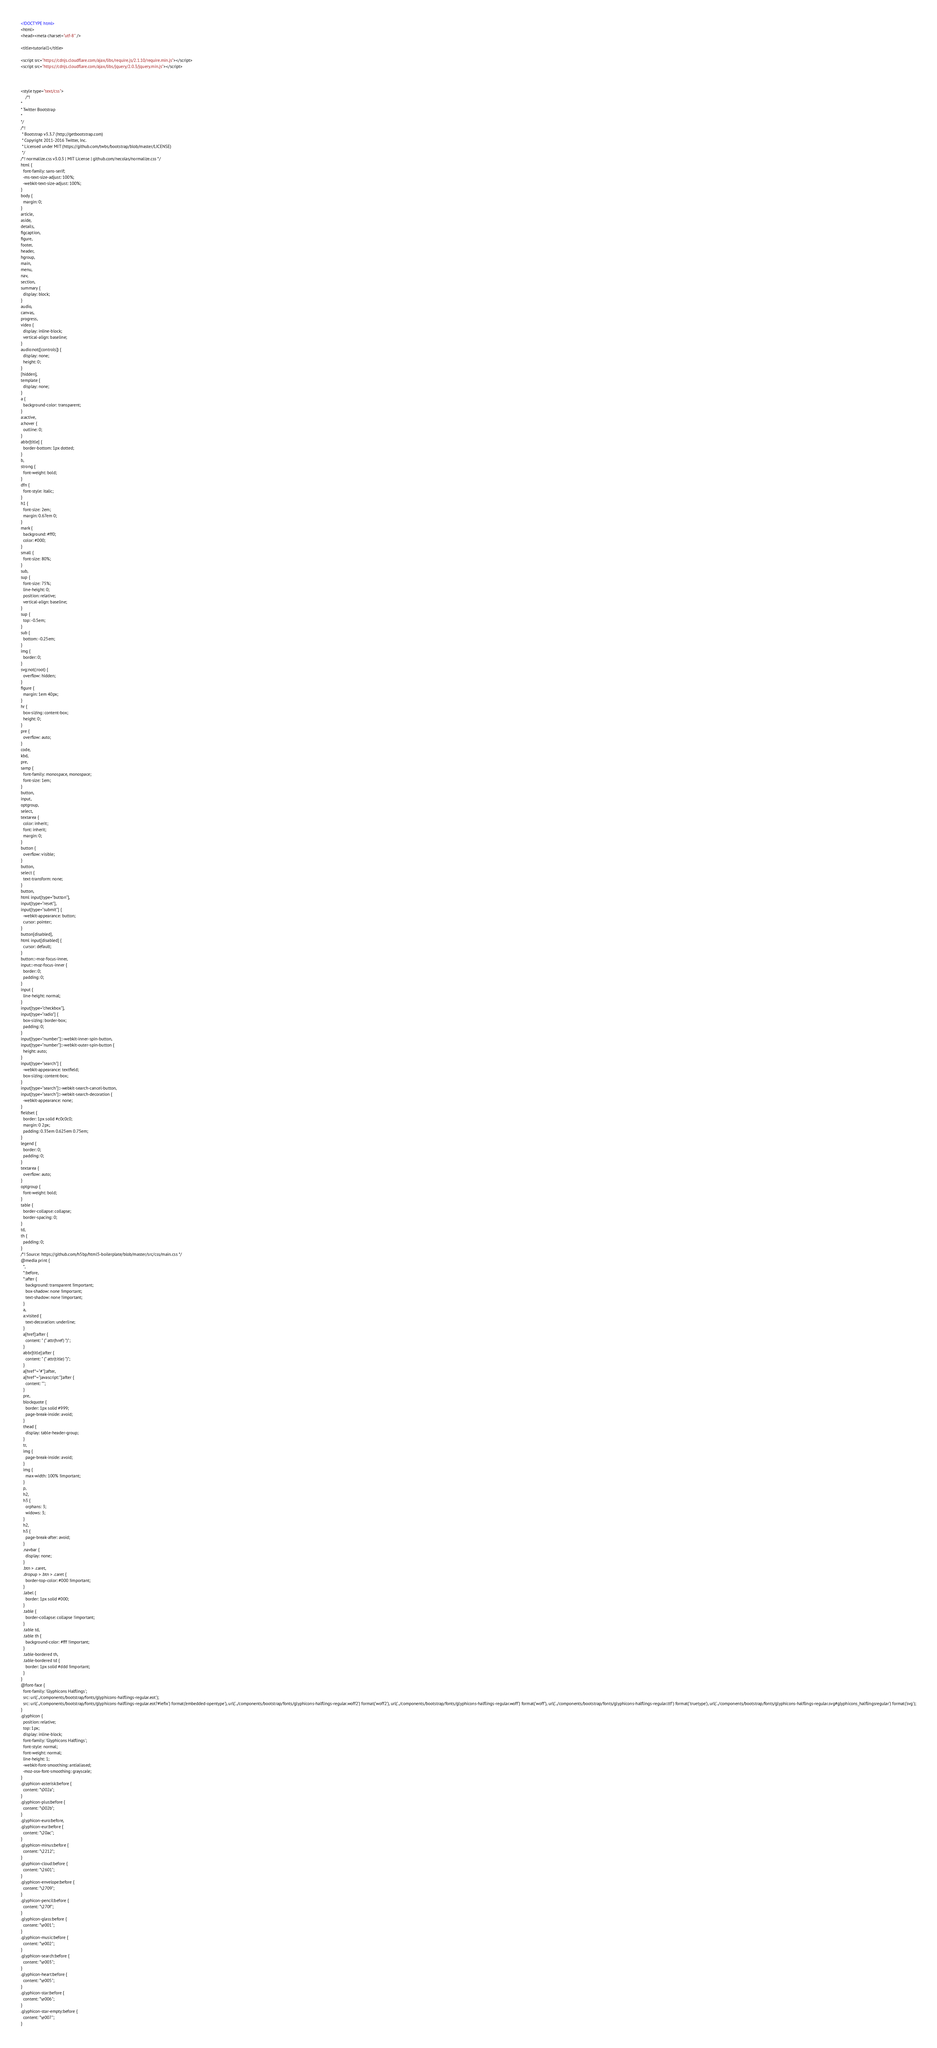Convert code to text. <code><loc_0><loc_0><loc_500><loc_500><_HTML_><!DOCTYPE html>
<html>
<head><meta charset="utf-8" />

<title>tutorial1</title>

<script src="https://cdnjs.cloudflare.com/ajax/libs/require.js/2.1.10/require.min.js"></script>
<script src="https://cdnjs.cloudflare.com/ajax/libs/jquery/2.0.3/jquery.min.js"></script>



<style type="text/css">
    /*!
*
* Twitter Bootstrap
*
*/
/*!
 * Bootstrap v3.3.7 (http://getbootstrap.com)
 * Copyright 2011-2016 Twitter, Inc.
 * Licensed under MIT (https://github.com/twbs/bootstrap/blob/master/LICENSE)
 */
/*! normalize.css v3.0.3 | MIT License | github.com/necolas/normalize.css */
html {
  font-family: sans-serif;
  -ms-text-size-adjust: 100%;
  -webkit-text-size-adjust: 100%;
}
body {
  margin: 0;
}
article,
aside,
details,
figcaption,
figure,
footer,
header,
hgroup,
main,
menu,
nav,
section,
summary {
  display: block;
}
audio,
canvas,
progress,
video {
  display: inline-block;
  vertical-align: baseline;
}
audio:not([controls]) {
  display: none;
  height: 0;
}
[hidden],
template {
  display: none;
}
a {
  background-color: transparent;
}
a:active,
a:hover {
  outline: 0;
}
abbr[title] {
  border-bottom: 1px dotted;
}
b,
strong {
  font-weight: bold;
}
dfn {
  font-style: italic;
}
h1 {
  font-size: 2em;
  margin: 0.67em 0;
}
mark {
  background: #ff0;
  color: #000;
}
small {
  font-size: 80%;
}
sub,
sup {
  font-size: 75%;
  line-height: 0;
  position: relative;
  vertical-align: baseline;
}
sup {
  top: -0.5em;
}
sub {
  bottom: -0.25em;
}
img {
  border: 0;
}
svg:not(:root) {
  overflow: hidden;
}
figure {
  margin: 1em 40px;
}
hr {
  box-sizing: content-box;
  height: 0;
}
pre {
  overflow: auto;
}
code,
kbd,
pre,
samp {
  font-family: monospace, monospace;
  font-size: 1em;
}
button,
input,
optgroup,
select,
textarea {
  color: inherit;
  font: inherit;
  margin: 0;
}
button {
  overflow: visible;
}
button,
select {
  text-transform: none;
}
button,
html input[type="button"],
input[type="reset"],
input[type="submit"] {
  -webkit-appearance: button;
  cursor: pointer;
}
button[disabled],
html input[disabled] {
  cursor: default;
}
button::-moz-focus-inner,
input::-moz-focus-inner {
  border: 0;
  padding: 0;
}
input {
  line-height: normal;
}
input[type="checkbox"],
input[type="radio"] {
  box-sizing: border-box;
  padding: 0;
}
input[type="number"]::-webkit-inner-spin-button,
input[type="number"]::-webkit-outer-spin-button {
  height: auto;
}
input[type="search"] {
  -webkit-appearance: textfield;
  box-sizing: content-box;
}
input[type="search"]::-webkit-search-cancel-button,
input[type="search"]::-webkit-search-decoration {
  -webkit-appearance: none;
}
fieldset {
  border: 1px solid #c0c0c0;
  margin: 0 2px;
  padding: 0.35em 0.625em 0.75em;
}
legend {
  border: 0;
  padding: 0;
}
textarea {
  overflow: auto;
}
optgroup {
  font-weight: bold;
}
table {
  border-collapse: collapse;
  border-spacing: 0;
}
td,
th {
  padding: 0;
}
/*! Source: https://github.com/h5bp/html5-boilerplate/blob/master/src/css/main.css */
@media print {
  *,
  *:before,
  *:after {
    background: transparent !important;
    box-shadow: none !important;
    text-shadow: none !important;
  }
  a,
  a:visited {
    text-decoration: underline;
  }
  a[href]:after {
    content: " (" attr(href) ")";
  }
  abbr[title]:after {
    content: " (" attr(title) ")";
  }
  a[href^="#"]:after,
  a[href^="javascript:"]:after {
    content: "";
  }
  pre,
  blockquote {
    border: 1px solid #999;
    page-break-inside: avoid;
  }
  thead {
    display: table-header-group;
  }
  tr,
  img {
    page-break-inside: avoid;
  }
  img {
    max-width: 100% !important;
  }
  p,
  h2,
  h3 {
    orphans: 3;
    widows: 3;
  }
  h2,
  h3 {
    page-break-after: avoid;
  }
  .navbar {
    display: none;
  }
  .btn > .caret,
  .dropup > .btn > .caret {
    border-top-color: #000 !important;
  }
  .label {
    border: 1px solid #000;
  }
  .table {
    border-collapse: collapse !important;
  }
  .table td,
  .table th {
    background-color: #fff !important;
  }
  .table-bordered th,
  .table-bordered td {
    border: 1px solid #ddd !important;
  }
}
@font-face {
  font-family: 'Glyphicons Halflings';
  src: url('../components/bootstrap/fonts/glyphicons-halflings-regular.eot');
  src: url('../components/bootstrap/fonts/glyphicons-halflings-regular.eot?#iefix') format('embedded-opentype'), url('../components/bootstrap/fonts/glyphicons-halflings-regular.woff2') format('woff2'), url('../components/bootstrap/fonts/glyphicons-halflings-regular.woff') format('woff'), url('../components/bootstrap/fonts/glyphicons-halflings-regular.ttf') format('truetype'), url('../components/bootstrap/fonts/glyphicons-halflings-regular.svg#glyphicons_halflingsregular') format('svg');
}
.glyphicon {
  position: relative;
  top: 1px;
  display: inline-block;
  font-family: 'Glyphicons Halflings';
  font-style: normal;
  font-weight: normal;
  line-height: 1;
  -webkit-font-smoothing: antialiased;
  -moz-osx-font-smoothing: grayscale;
}
.glyphicon-asterisk:before {
  content: "\002a";
}
.glyphicon-plus:before {
  content: "\002b";
}
.glyphicon-euro:before,
.glyphicon-eur:before {
  content: "\20ac";
}
.glyphicon-minus:before {
  content: "\2212";
}
.glyphicon-cloud:before {
  content: "\2601";
}
.glyphicon-envelope:before {
  content: "\2709";
}
.glyphicon-pencil:before {
  content: "\270f";
}
.glyphicon-glass:before {
  content: "\e001";
}
.glyphicon-music:before {
  content: "\e002";
}
.glyphicon-search:before {
  content: "\e003";
}
.glyphicon-heart:before {
  content: "\e005";
}
.glyphicon-star:before {
  content: "\e006";
}
.glyphicon-star-empty:before {
  content: "\e007";
}</code> 